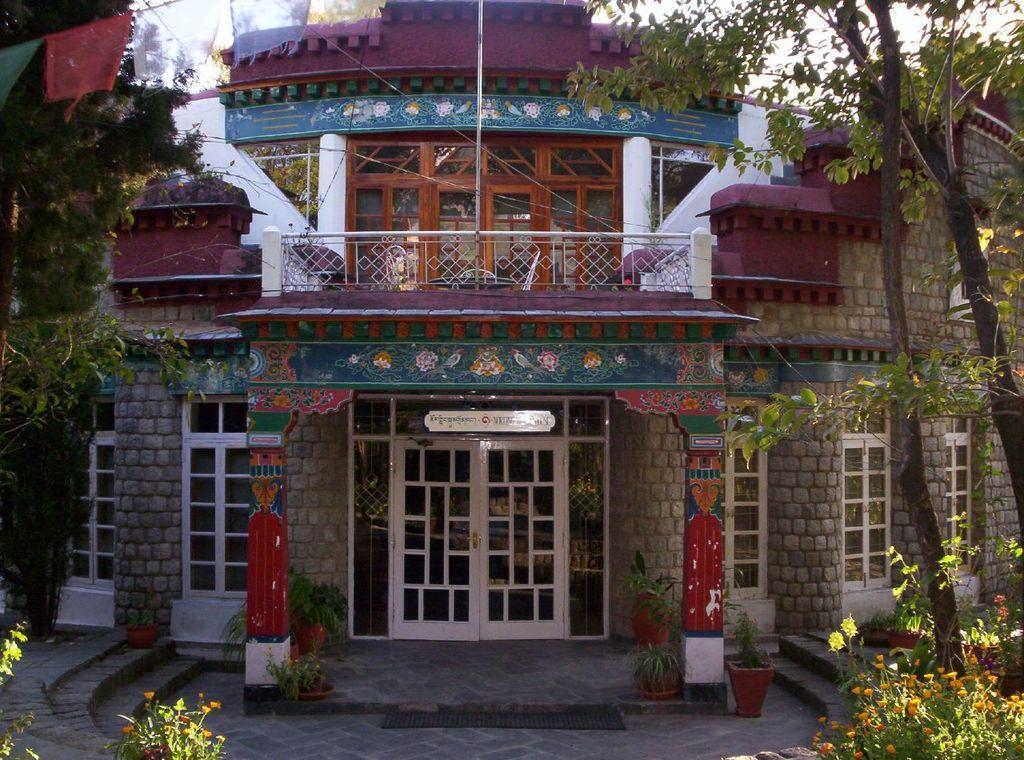Can you describe this image briefly? In this picture we can see a building with doors and windows, here we can see a name board, house plants, plants with flowers and in the background we can see trees, flags, sky. 